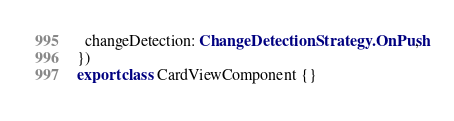<code> <loc_0><loc_0><loc_500><loc_500><_TypeScript_>  changeDetection: ChangeDetectionStrategy.OnPush,
})
export class CardViewComponent {}
</code> 